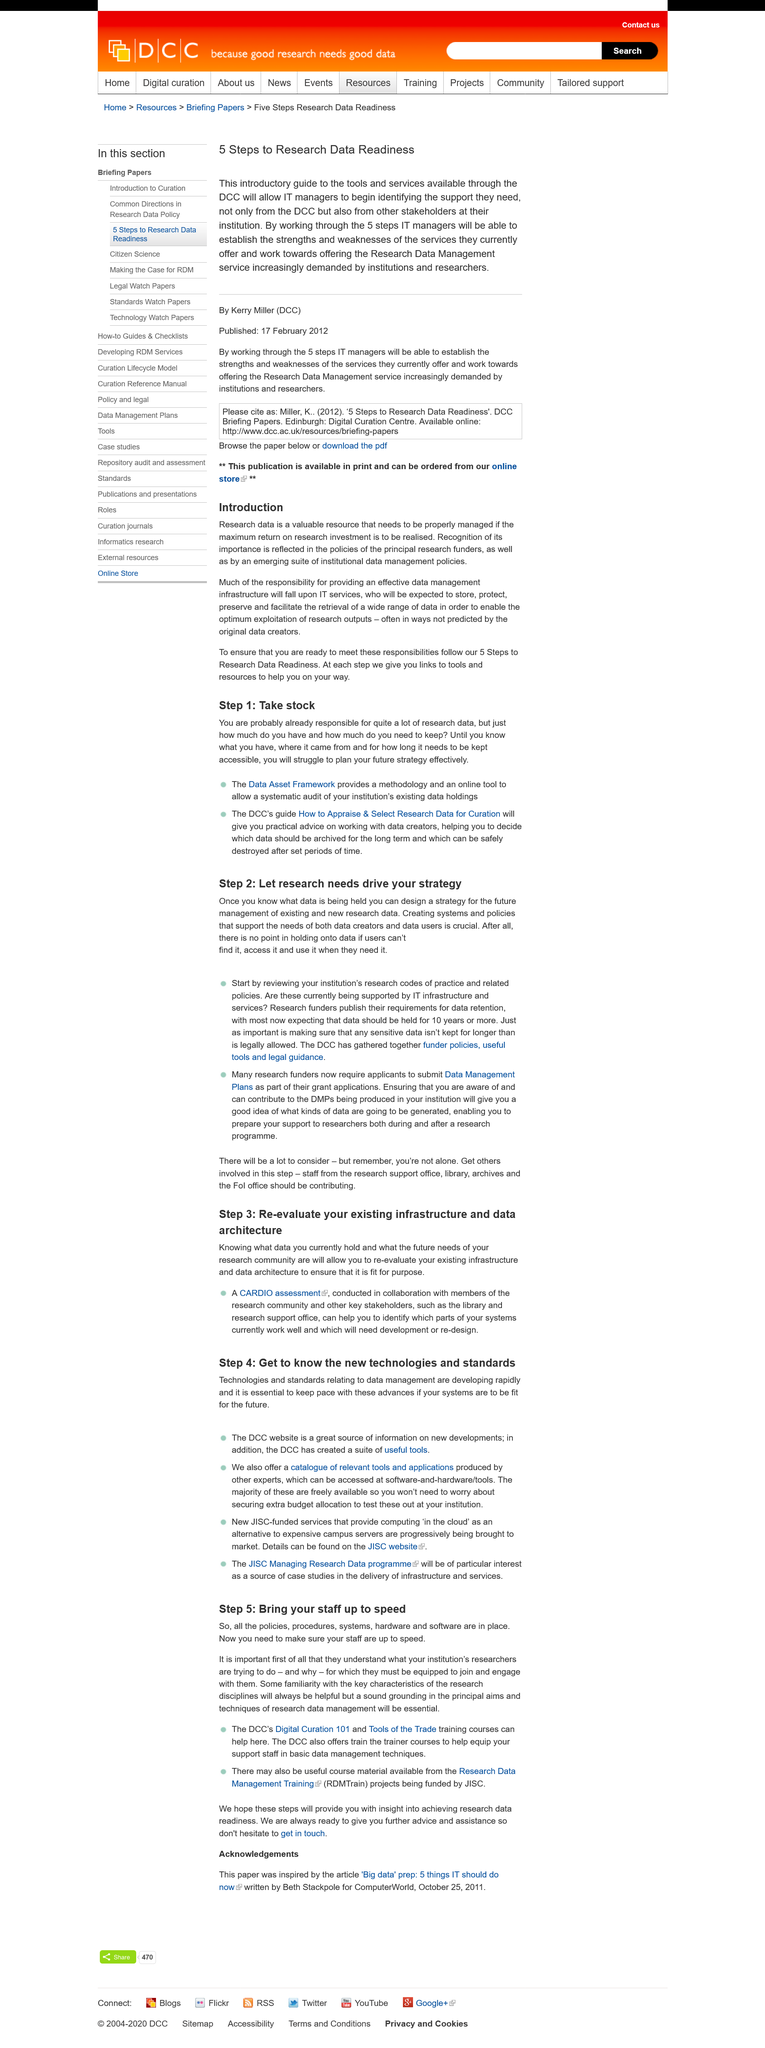Point out several critical features in this image. Research data readiness consists of five steps. IT services are primarily responsible for providing effective data management infrastructure, as this is a critical component of modern technology systems. To fulfill the obligation of establishing a reliable data management system, one should adhere to the following five steps to ensure Research Data Readiness. 